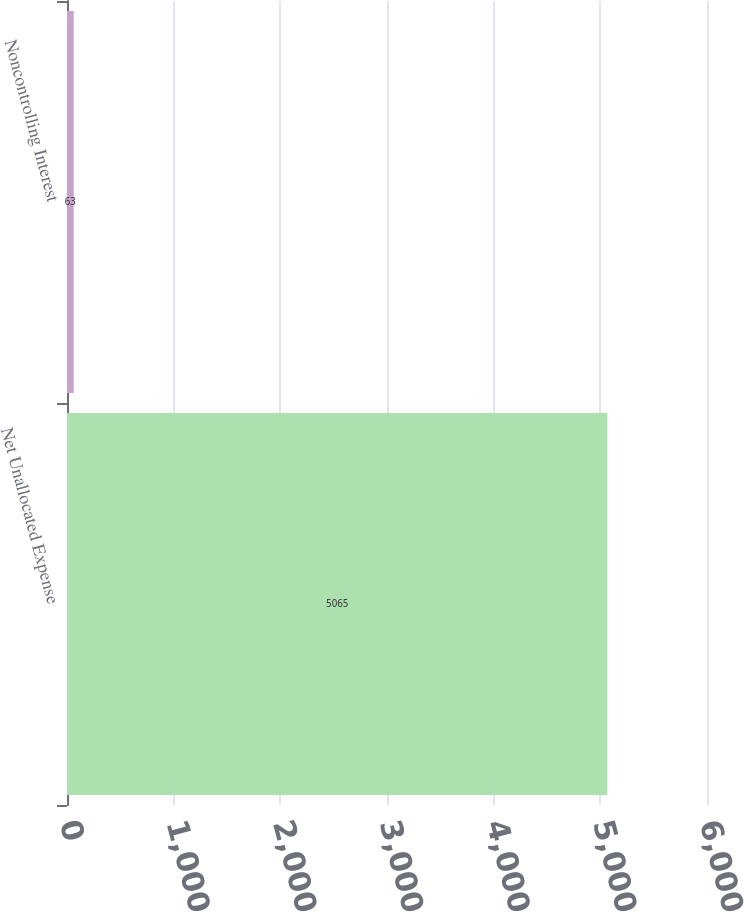Convert chart to OTSL. <chart><loc_0><loc_0><loc_500><loc_500><bar_chart><fcel>Net Unallocated Expense<fcel>Noncontrolling Interest<nl><fcel>5065<fcel>63<nl></chart> 